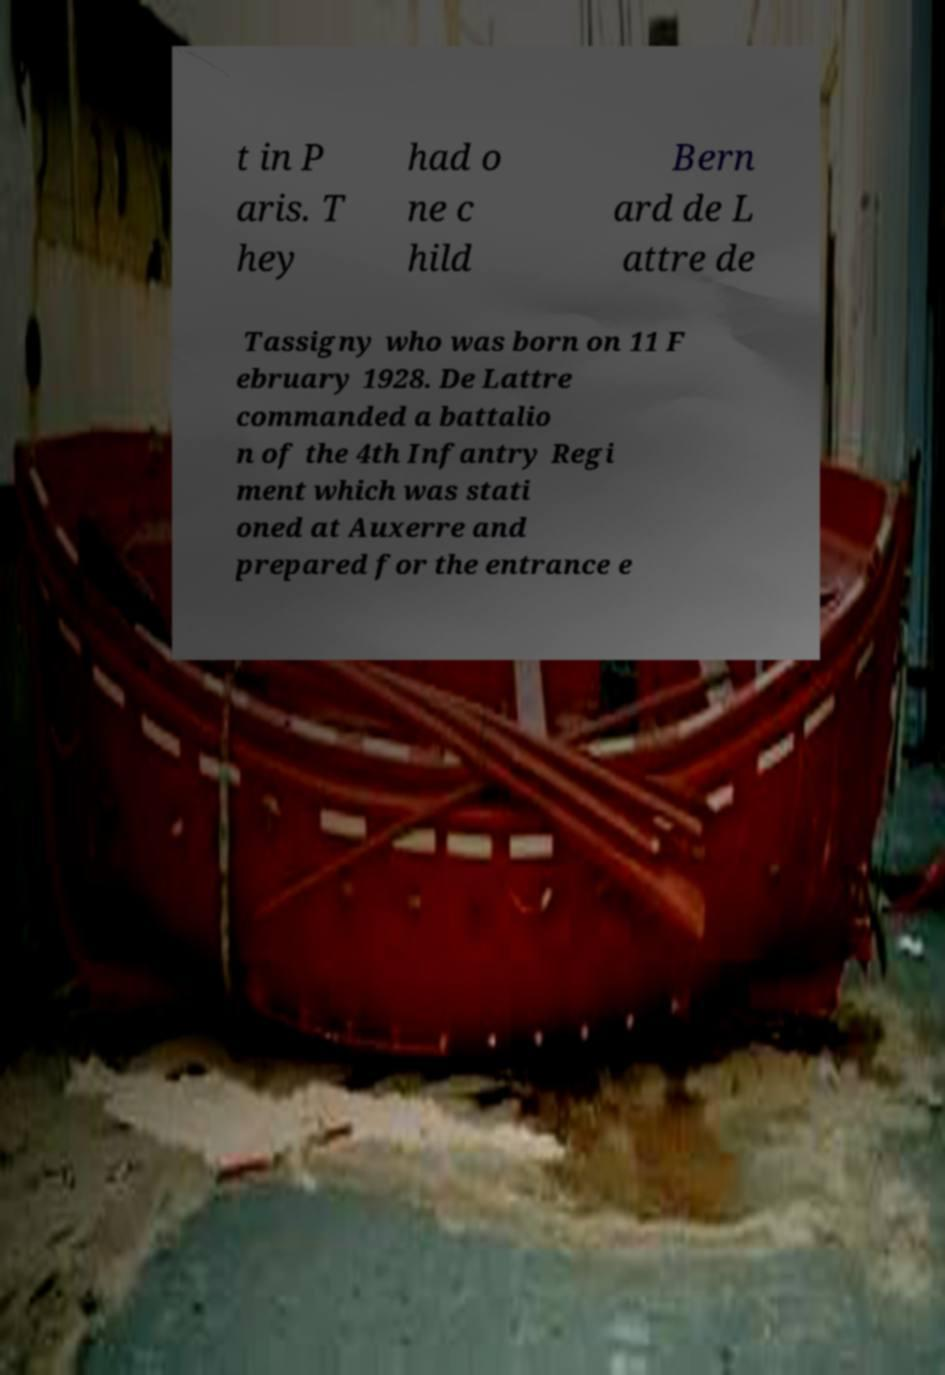Can you read and provide the text displayed in the image?This photo seems to have some interesting text. Can you extract and type it out for me? t in P aris. T hey had o ne c hild Bern ard de L attre de Tassigny who was born on 11 F ebruary 1928. De Lattre commanded a battalio n of the 4th Infantry Regi ment which was stati oned at Auxerre and prepared for the entrance e 